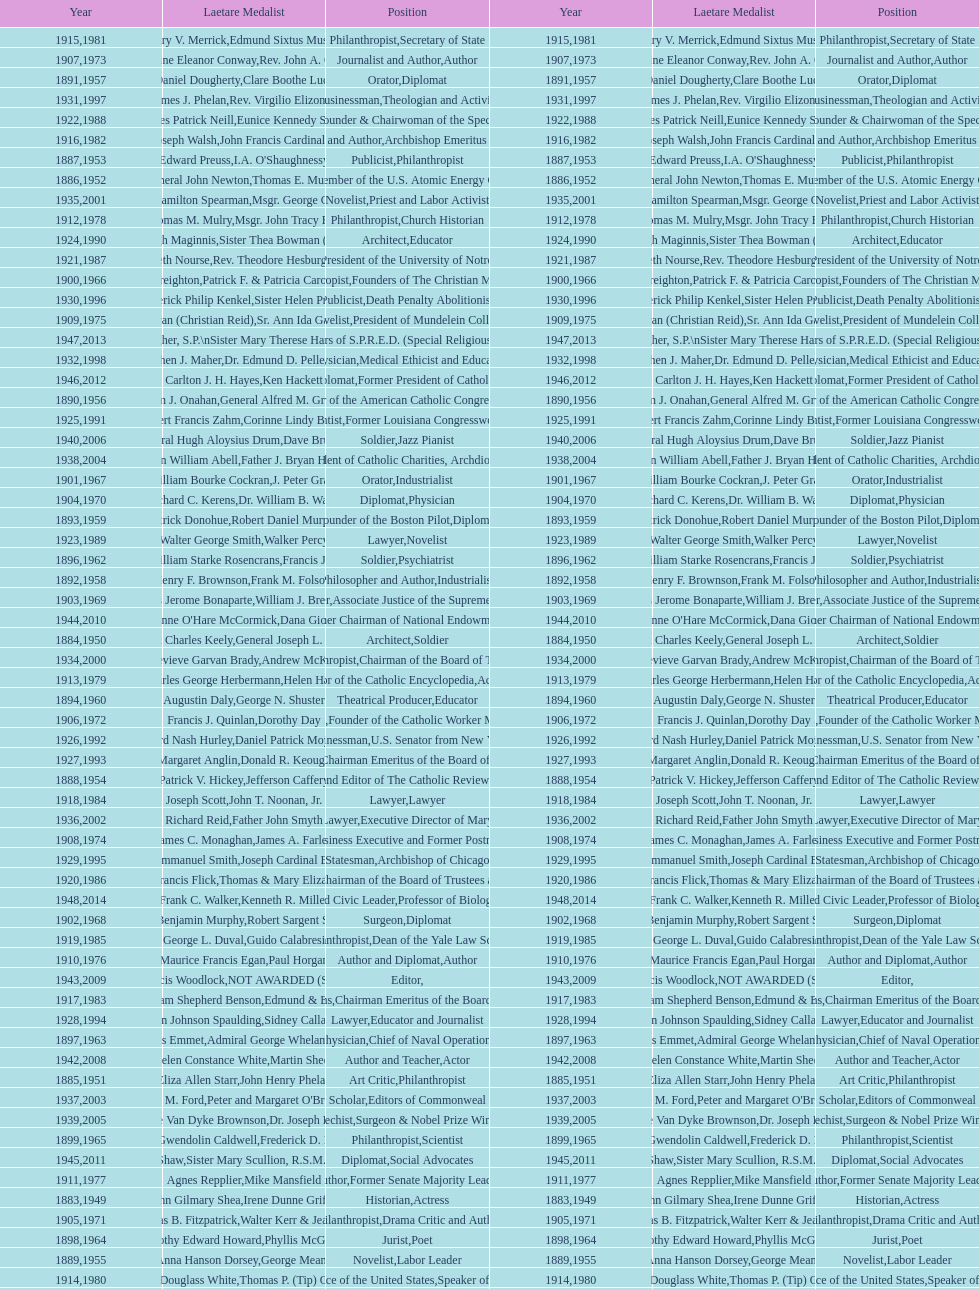Who was the previous winner before john henry phelan in 1951? General Joseph L. Collins. 